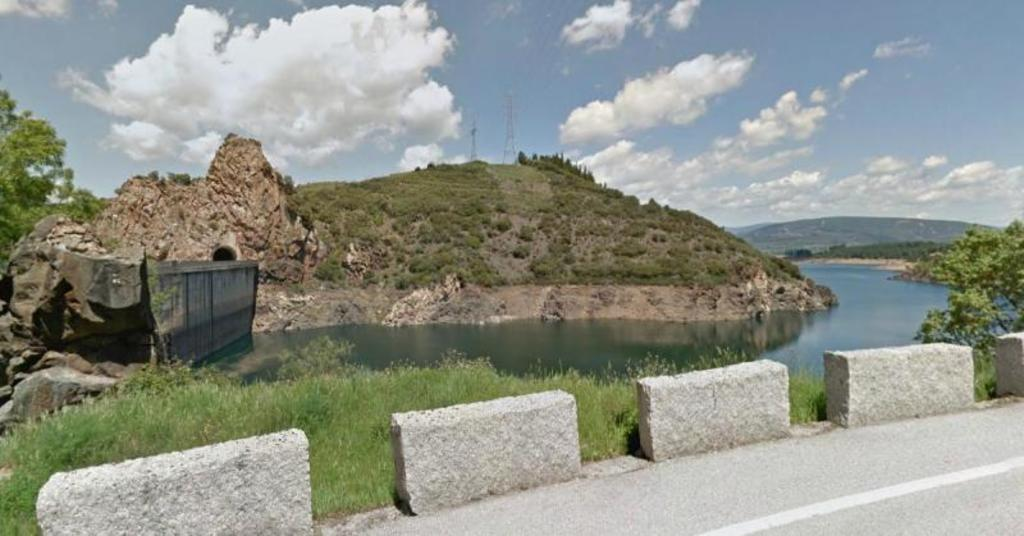What is the weather like in the image? The sky in the image is cloudy, indicating a potentially overcast or cloudy day. What type of geographical feature can be seen in the image? There are mountains visible in the image. How many antennas are present in the image? There are two antennas in the image. What type of water feature is present in the image? There is a river in the image. What type of vegetation is present in the image? Trees, bushes, and grass are present in the image. What type of pathway is visible in the image? There is a road in the image. What type of rock formation is present in the image? Rocks are present in the image. What type of treatment is being administered to the leg in the image? There is no leg or treatment visible in the image. What type of van is parked near the river in the image? There is no van present in the image. 